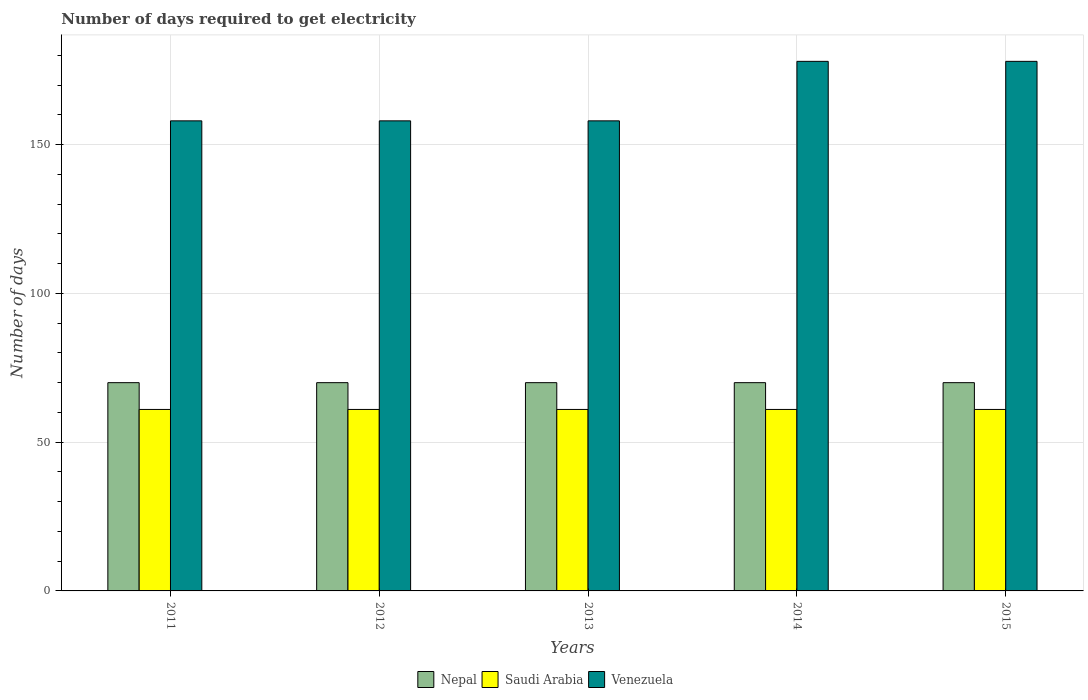How many groups of bars are there?
Your answer should be very brief. 5. How many bars are there on the 3rd tick from the left?
Offer a terse response. 3. How many bars are there on the 1st tick from the right?
Make the answer very short. 3. In how many cases, is the number of bars for a given year not equal to the number of legend labels?
Your answer should be very brief. 0. What is the number of days required to get electricity in in Saudi Arabia in 2011?
Give a very brief answer. 61. Across all years, what is the maximum number of days required to get electricity in in Saudi Arabia?
Provide a succinct answer. 61. Across all years, what is the minimum number of days required to get electricity in in Saudi Arabia?
Offer a very short reply. 61. In which year was the number of days required to get electricity in in Saudi Arabia maximum?
Ensure brevity in your answer.  2011. What is the total number of days required to get electricity in in Venezuela in the graph?
Make the answer very short. 830. What is the difference between the number of days required to get electricity in in Venezuela in 2011 and that in 2014?
Provide a short and direct response. -20. What is the difference between the number of days required to get electricity in in Venezuela in 2011 and the number of days required to get electricity in in Saudi Arabia in 2013?
Ensure brevity in your answer.  97. What is the average number of days required to get electricity in in Saudi Arabia per year?
Give a very brief answer. 61. In the year 2011, what is the difference between the number of days required to get electricity in in Nepal and number of days required to get electricity in in Saudi Arabia?
Your answer should be compact. 9. Is the number of days required to get electricity in in Venezuela in 2011 less than that in 2012?
Provide a short and direct response. No. Is the sum of the number of days required to get electricity in in Saudi Arabia in 2014 and 2015 greater than the maximum number of days required to get electricity in in Nepal across all years?
Offer a terse response. Yes. What does the 1st bar from the left in 2015 represents?
Your response must be concise. Nepal. What does the 2nd bar from the right in 2013 represents?
Your response must be concise. Saudi Arabia. How many bars are there?
Make the answer very short. 15. Are all the bars in the graph horizontal?
Ensure brevity in your answer.  No. How many years are there in the graph?
Provide a short and direct response. 5. What is the difference between two consecutive major ticks on the Y-axis?
Offer a terse response. 50. Are the values on the major ticks of Y-axis written in scientific E-notation?
Offer a terse response. No. Does the graph contain grids?
Keep it short and to the point. Yes. Where does the legend appear in the graph?
Your answer should be very brief. Bottom center. What is the title of the graph?
Your answer should be very brief. Number of days required to get electricity. What is the label or title of the X-axis?
Your answer should be compact. Years. What is the label or title of the Y-axis?
Keep it short and to the point. Number of days. What is the Number of days in Nepal in 2011?
Provide a succinct answer. 70. What is the Number of days in Venezuela in 2011?
Keep it short and to the point. 158. What is the Number of days of Venezuela in 2012?
Keep it short and to the point. 158. What is the Number of days of Saudi Arabia in 2013?
Keep it short and to the point. 61. What is the Number of days in Venezuela in 2013?
Ensure brevity in your answer.  158. What is the Number of days in Nepal in 2014?
Provide a succinct answer. 70. What is the Number of days of Saudi Arabia in 2014?
Provide a short and direct response. 61. What is the Number of days of Venezuela in 2014?
Keep it short and to the point. 178. What is the Number of days of Venezuela in 2015?
Your response must be concise. 178. Across all years, what is the maximum Number of days in Nepal?
Ensure brevity in your answer.  70. Across all years, what is the maximum Number of days of Venezuela?
Offer a terse response. 178. Across all years, what is the minimum Number of days of Saudi Arabia?
Provide a succinct answer. 61. Across all years, what is the minimum Number of days of Venezuela?
Ensure brevity in your answer.  158. What is the total Number of days in Nepal in the graph?
Your answer should be compact. 350. What is the total Number of days of Saudi Arabia in the graph?
Provide a short and direct response. 305. What is the total Number of days in Venezuela in the graph?
Ensure brevity in your answer.  830. What is the difference between the Number of days in Nepal in 2011 and that in 2012?
Keep it short and to the point. 0. What is the difference between the Number of days in Venezuela in 2011 and that in 2012?
Offer a terse response. 0. What is the difference between the Number of days in Saudi Arabia in 2011 and that in 2013?
Your answer should be very brief. 0. What is the difference between the Number of days of Nepal in 2011 and that in 2014?
Provide a succinct answer. 0. What is the difference between the Number of days of Venezuela in 2011 and that in 2014?
Ensure brevity in your answer.  -20. What is the difference between the Number of days of Nepal in 2011 and that in 2015?
Offer a terse response. 0. What is the difference between the Number of days in Saudi Arabia in 2011 and that in 2015?
Ensure brevity in your answer.  0. What is the difference between the Number of days in Venezuela in 2011 and that in 2015?
Provide a short and direct response. -20. What is the difference between the Number of days in Saudi Arabia in 2012 and that in 2013?
Provide a succinct answer. 0. What is the difference between the Number of days in Venezuela in 2012 and that in 2013?
Your answer should be compact. 0. What is the difference between the Number of days of Saudi Arabia in 2012 and that in 2014?
Your answer should be very brief. 0. What is the difference between the Number of days in Saudi Arabia in 2012 and that in 2015?
Keep it short and to the point. 0. What is the difference between the Number of days in Saudi Arabia in 2013 and that in 2014?
Your answer should be compact. 0. What is the difference between the Number of days of Venezuela in 2013 and that in 2014?
Offer a terse response. -20. What is the difference between the Number of days of Saudi Arabia in 2013 and that in 2015?
Provide a succinct answer. 0. What is the difference between the Number of days in Venezuela in 2014 and that in 2015?
Provide a succinct answer. 0. What is the difference between the Number of days of Nepal in 2011 and the Number of days of Venezuela in 2012?
Provide a succinct answer. -88. What is the difference between the Number of days in Saudi Arabia in 2011 and the Number of days in Venezuela in 2012?
Your response must be concise. -97. What is the difference between the Number of days of Nepal in 2011 and the Number of days of Venezuela in 2013?
Provide a short and direct response. -88. What is the difference between the Number of days in Saudi Arabia in 2011 and the Number of days in Venezuela in 2013?
Provide a succinct answer. -97. What is the difference between the Number of days of Nepal in 2011 and the Number of days of Venezuela in 2014?
Make the answer very short. -108. What is the difference between the Number of days of Saudi Arabia in 2011 and the Number of days of Venezuela in 2014?
Offer a very short reply. -117. What is the difference between the Number of days in Nepal in 2011 and the Number of days in Saudi Arabia in 2015?
Make the answer very short. 9. What is the difference between the Number of days in Nepal in 2011 and the Number of days in Venezuela in 2015?
Provide a short and direct response. -108. What is the difference between the Number of days of Saudi Arabia in 2011 and the Number of days of Venezuela in 2015?
Give a very brief answer. -117. What is the difference between the Number of days of Nepal in 2012 and the Number of days of Saudi Arabia in 2013?
Your answer should be compact. 9. What is the difference between the Number of days in Nepal in 2012 and the Number of days in Venezuela in 2013?
Ensure brevity in your answer.  -88. What is the difference between the Number of days of Saudi Arabia in 2012 and the Number of days of Venezuela in 2013?
Your answer should be very brief. -97. What is the difference between the Number of days of Nepal in 2012 and the Number of days of Saudi Arabia in 2014?
Make the answer very short. 9. What is the difference between the Number of days of Nepal in 2012 and the Number of days of Venezuela in 2014?
Your response must be concise. -108. What is the difference between the Number of days in Saudi Arabia in 2012 and the Number of days in Venezuela in 2014?
Provide a short and direct response. -117. What is the difference between the Number of days in Nepal in 2012 and the Number of days in Saudi Arabia in 2015?
Ensure brevity in your answer.  9. What is the difference between the Number of days of Nepal in 2012 and the Number of days of Venezuela in 2015?
Provide a short and direct response. -108. What is the difference between the Number of days in Saudi Arabia in 2012 and the Number of days in Venezuela in 2015?
Your answer should be very brief. -117. What is the difference between the Number of days of Nepal in 2013 and the Number of days of Saudi Arabia in 2014?
Ensure brevity in your answer.  9. What is the difference between the Number of days of Nepal in 2013 and the Number of days of Venezuela in 2014?
Your response must be concise. -108. What is the difference between the Number of days of Saudi Arabia in 2013 and the Number of days of Venezuela in 2014?
Make the answer very short. -117. What is the difference between the Number of days of Nepal in 2013 and the Number of days of Venezuela in 2015?
Offer a terse response. -108. What is the difference between the Number of days in Saudi Arabia in 2013 and the Number of days in Venezuela in 2015?
Your answer should be very brief. -117. What is the difference between the Number of days in Nepal in 2014 and the Number of days in Saudi Arabia in 2015?
Offer a very short reply. 9. What is the difference between the Number of days of Nepal in 2014 and the Number of days of Venezuela in 2015?
Your answer should be very brief. -108. What is the difference between the Number of days of Saudi Arabia in 2014 and the Number of days of Venezuela in 2015?
Your answer should be very brief. -117. What is the average Number of days in Venezuela per year?
Ensure brevity in your answer.  166. In the year 2011, what is the difference between the Number of days of Nepal and Number of days of Venezuela?
Your response must be concise. -88. In the year 2011, what is the difference between the Number of days in Saudi Arabia and Number of days in Venezuela?
Your answer should be compact. -97. In the year 2012, what is the difference between the Number of days of Nepal and Number of days of Saudi Arabia?
Make the answer very short. 9. In the year 2012, what is the difference between the Number of days of Nepal and Number of days of Venezuela?
Give a very brief answer. -88. In the year 2012, what is the difference between the Number of days in Saudi Arabia and Number of days in Venezuela?
Provide a succinct answer. -97. In the year 2013, what is the difference between the Number of days in Nepal and Number of days in Venezuela?
Your answer should be compact. -88. In the year 2013, what is the difference between the Number of days of Saudi Arabia and Number of days of Venezuela?
Keep it short and to the point. -97. In the year 2014, what is the difference between the Number of days in Nepal and Number of days in Venezuela?
Provide a short and direct response. -108. In the year 2014, what is the difference between the Number of days in Saudi Arabia and Number of days in Venezuela?
Offer a very short reply. -117. In the year 2015, what is the difference between the Number of days of Nepal and Number of days of Venezuela?
Your answer should be very brief. -108. In the year 2015, what is the difference between the Number of days of Saudi Arabia and Number of days of Venezuela?
Your answer should be compact. -117. What is the ratio of the Number of days in Nepal in 2011 to that in 2012?
Your answer should be very brief. 1. What is the ratio of the Number of days in Venezuela in 2011 to that in 2012?
Ensure brevity in your answer.  1. What is the ratio of the Number of days of Nepal in 2011 to that in 2013?
Give a very brief answer. 1. What is the ratio of the Number of days of Venezuela in 2011 to that in 2013?
Keep it short and to the point. 1. What is the ratio of the Number of days of Nepal in 2011 to that in 2014?
Give a very brief answer. 1. What is the ratio of the Number of days in Saudi Arabia in 2011 to that in 2014?
Keep it short and to the point. 1. What is the ratio of the Number of days of Venezuela in 2011 to that in 2014?
Give a very brief answer. 0.89. What is the ratio of the Number of days in Venezuela in 2011 to that in 2015?
Ensure brevity in your answer.  0.89. What is the ratio of the Number of days of Nepal in 2012 to that in 2013?
Offer a terse response. 1. What is the ratio of the Number of days in Venezuela in 2012 to that in 2014?
Keep it short and to the point. 0.89. What is the ratio of the Number of days in Nepal in 2012 to that in 2015?
Ensure brevity in your answer.  1. What is the ratio of the Number of days of Saudi Arabia in 2012 to that in 2015?
Offer a terse response. 1. What is the ratio of the Number of days of Venezuela in 2012 to that in 2015?
Offer a terse response. 0.89. What is the ratio of the Number of days of Venezuela in 2013 to that in 2014?
Your answer should be compact. 0.89. What is the ratio of the Number of days of Nepal in 2013 to that in 2015?
Make the answer very short. 1. What is the ratio of the Number of days in Venezuela in 2013 to that in 2015?
Your answer should be compact. 0.89. What is the ratio of the Number of days in Venezuela in 2014 to that in 2015?
Your answer should be compact. 1. What is the difference between the highest and the second highest Number of days in Saudi Arabia?
Give a very brief answer. 0. What is the difference between the highest and the second highest Number of days in Venezuela?
Offer a very short reply. 0. What is the difference between the highest and the lowest Number of days of Venezuela?
Provide a succinct answer. 20. 